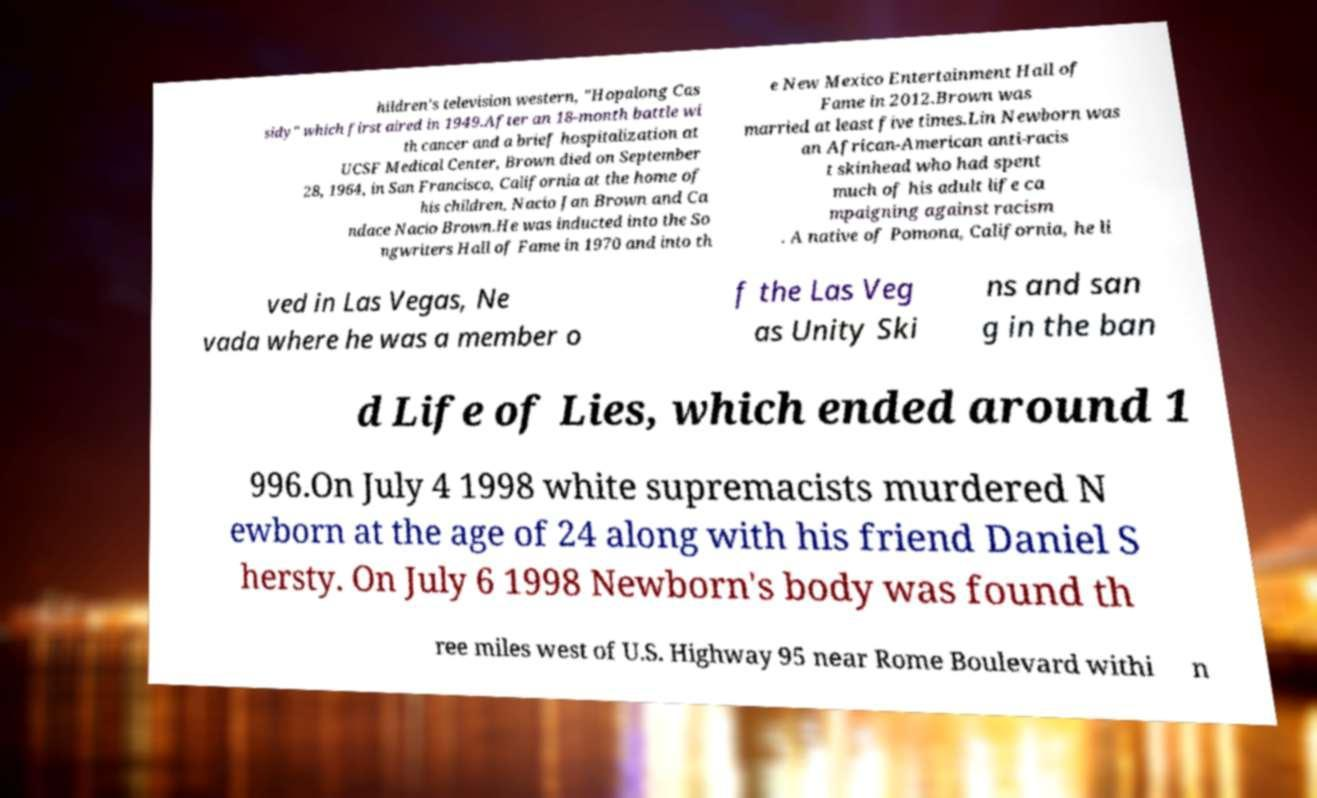Please identify and transcribe the text found in this image. hildren's television western, "Hopalong Cas sidy" which first aired in 1949.After an 18-month battle wi th cancer and a brief hospitalization at UCSF Medical Center, Brown died on September 28, 1964, in San Francisco, California at the home of his children, Nacio Jan Brown and Ca ndace Nacio Brown.He was inducted into the So ngwriters Hall of Fame in 1970 and into th e New Mexico Entertainment Hall of Fame in 2012.Brown was married at least five times.Lin Newborn was an African-American anti-racis t skinhead who had spent much of his adult life ca mpaigning against racism . A native of Pomona, California, he li ved in Las Vegas, Ne vada where he was a member o f the Las Veg as Unity Ski ns and san g in the ban d Life of Lies, which ended around 1 996.On July 4 1998 white supremacists murdered N ewborn at the age of 24 along with his friend Daniel S hersty. On July 6 1998 Newborn's body was found th ree miles west of U.S. Highway 95 near Rome Boulevard withi n 